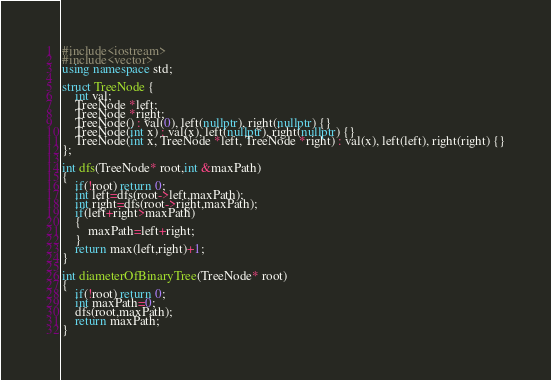Convert code to text. <code><loc_0><loc_0><loc_500><loc_500><_C++_>#include<iostream>
#include<vector>
using namespace std;

struct TreeNode {
    int val;
    TreeNode *left;
    TreeNode *right;
    TreeNode() : val(0), left(nullptr), right(nullptr) {}
    TreeNode(int x) : val(x), left(nullptr), right(nullptr) {}
    TreeNode(int x, TreeNode *left, TreeNode *right) : val(x), left(left), right(right) {}
};

int dfs(TreeNode* root,int &maxPath)
{
    if(!root) return 0;
    int left=dfs(root->left,maxPath);
    int right=dfs(root->right,maxPath);
    if(left+right>maxPath)
    {
        maxPath=left+right;
    }
    return max(left,right)+1;
}

int diameterOfBinaryTree(TreeNode* root)
{
    if(!root) return 0;
    int maxPath=0;
    dfs(root,maxPath);
    return maxPath;
}</code> 